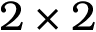<formula> <loc_0><loc_0><loc_500><loc_500>2 \times 2</formula> 